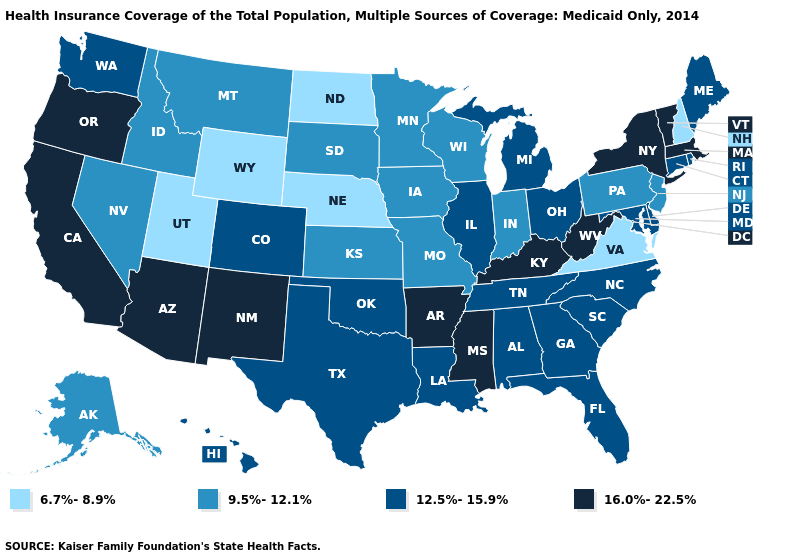What is the lowest value in the USA?
Quick response, please. 6.7%-8.9%. Name the states that have a value in the range 12.5%-15.9%?
Answer briefly. Alabama, Colorado, Connecticut, Delaware, Florida, Georgia, Hawaii, Illinois, Louisiana, Maine, Maryland, Michigan, North Carolina, Ohio, Oklahoma, Rhode Island, South Carolina, Tennessee, Texas, Washington. How many symbols are there in the legend?
Be succinct. 4. Does Rhode Island have the highest value in the Northeast?
Keep it brief. No. Which states have the lowest value in the South?
Give a very brief answer. Virginia. Does the first symbol in the legend represent the smallest category?
Write a very short answer. Yes. Among the states that border New York , which have the lowest value?
Be succinct. New Jersey, Pennsylvania. Does Pennsylvania have the lowest value in the Northeast?
Concise answer only. No. Does Arizona have the highest value in the USA?
Write a very short answer. Yes. Which states have the lowest value in the USA?
Give a very brief answer. Nebraska, New Hampshire, North Dakota, Utah, Virginia, Wyoming. Does the first symbol in the legend represent the smallest category?
Write a very short answer. Yes. Does New Hampshire have the lowest value in the USA?
Short answer required. Yes. What is the value of Pennsylvania?
Keep it brief. 9.5%-12.1%. Does Vermont have a higher value than Nebraska?
Short answer required. Yes. What is the value of South Dakota?
Concise answer only. 9.5%-12.1%. 